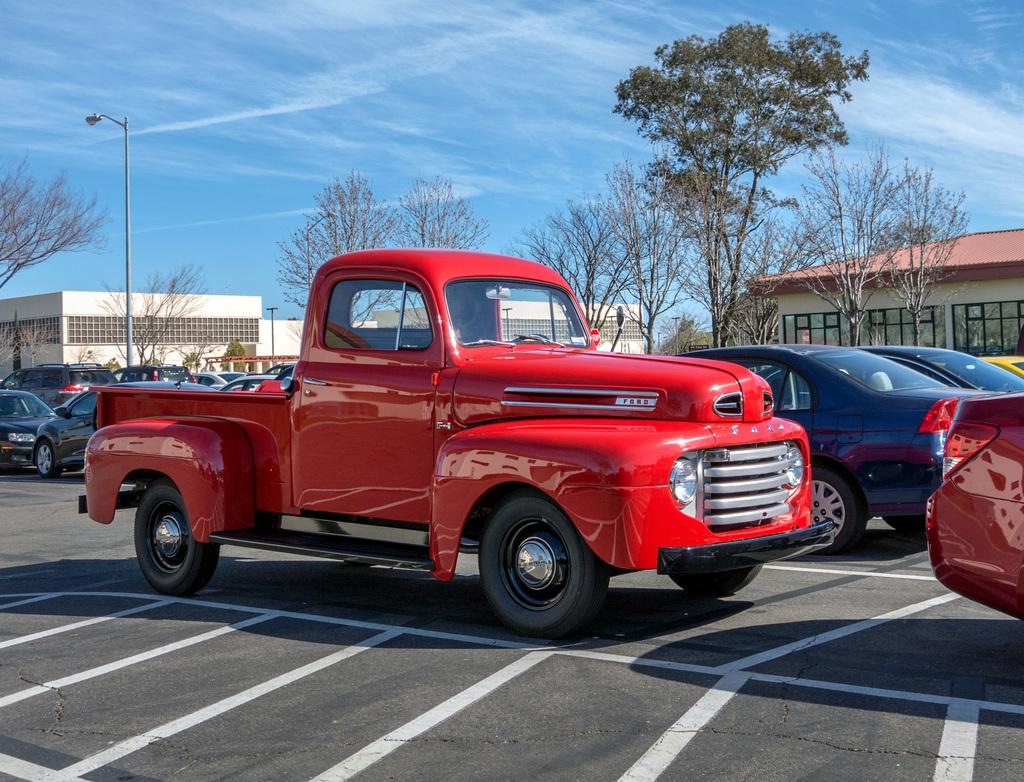What can be seen on the road in the image? There are vehicles parked on the road in the image. What is visible in the background of the image? There are buildings, trees, a light pole, and a house in the background. What is the condition of the sky in the image? The sky is visible with clouds in the image. Can you see a cow swimming near the vehicles in the image? No, there is no cow or swimming activity present in the image. Is there an arch visible in the background of the image? No, there is no arch present in the image. 